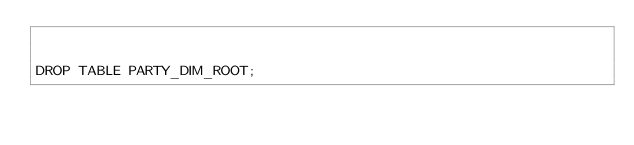<code> <loc_0><loc_0><loc_500><loc_500><_SQL_>

DROP TABLE PARTY_DIM_ROOT;

</code> 